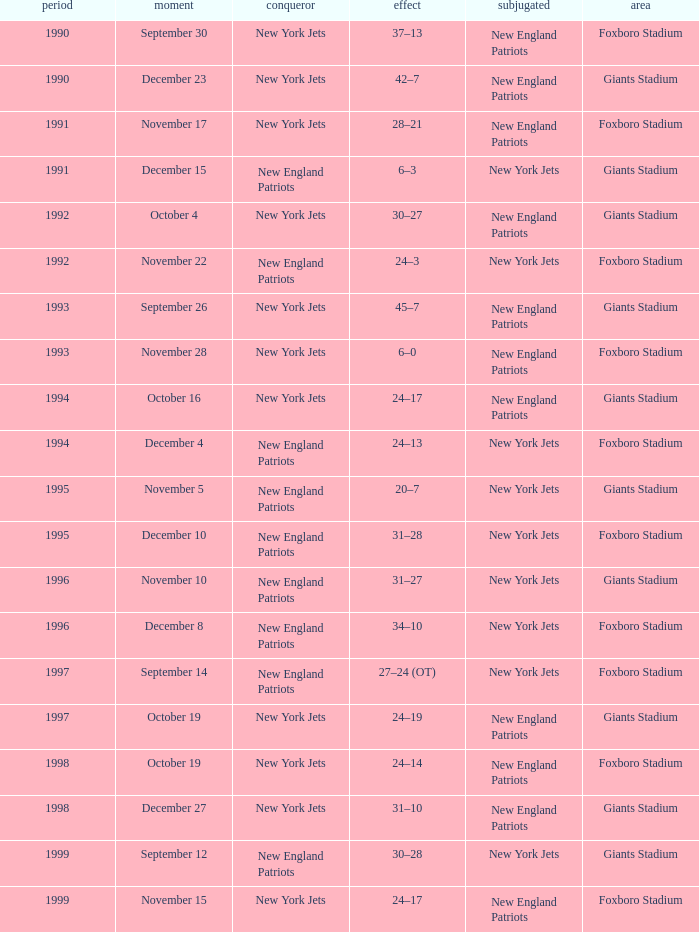What is the year when the Winner was the new york jets, with a Result of 24–17, played at giants stadium? 1994.0. Could you parse the entire table as a dict? {'header': ['period', 'moment', 'conqueror', 'effect', 'subjugated', 'area'], 'rows': [['1990', 'September 30', 'New York Jets', '37–13', 'New England Patriots', 'Foxboro Stadium'], ['1990', 'December 23', 'New York Jets', '42–7', 'New England Patriots', 'Giants Stadium'], ['1991', 'November 17', 'New York Jets', '28–21', 'New England Patriots', 'Foxboro Stadium'], ['1991', 'December 15', 'New England Patriots', '6–3', 'New York Jets', 'Giants Stadium'], ['1992', 'October 4', 'New York Jets', '30–27', 'New England Patriots', 'Giants Stadium'], ['1992', 'November 22', 'New England Patriots', '24–3', 'New York Jets', 'Foxboro Stadium'], ['1993', 'September 26', 'New York Jets', '45–7', 'New England Patriots', 'Giants Stadium'], ['1993', 'November 28', 'New York Jets', '6–0', 'New England Patriots', 'Foxboro Stadium'], ['1994', 'October 16', 'New York Jets', '24–17', 'New England Patriots', 'Giants Stadium'], ['1994', 'December 4', 'New England Patriots', '24–13', 'New York Jets', 'Foxboro Stadium'], ['1995', 'November 5', 'New England Patriots', '20–7', 'New York Jets', 'Giants Stadium'], ['1995', 'December 10', 'New England Patriots', '31–28', 'New York Jets', 'Foxboro Stadium'], ['1996', 'November 10', 'New England Patriots', '31–27', 'New York Jets', 'Giants Stadium'], ['1996', 'December 8', 'New England Patriots', '34–10', 'New York Jets', 'Foxboro Stadium'], ['1997', 'September 14', 'New England Patriots', '27–24 (OT)', 'New York Jets', 'Foxboro Stadium'], ['1997', 'October 19', 'New York Jets', '24–19', 'New England Patriots', 'Giants Stadium'], ['1998', 'October 19', 'New York Jets', '24–14', 'New England Patriots', 'Foxboro Stadium'], ['1998', 'December 27', 'New York Jets', '31–10', 'New England Patriots', 'Giants Stadium'], ['1999', 'September 12', 'New England Patriots', '30–28', 'New York Jets', 'Giants Stadium'], ['1999', 'November 15', 'New York Jets', '24–17', 'New England Patriots', 'Foxboro Stadium']]} 